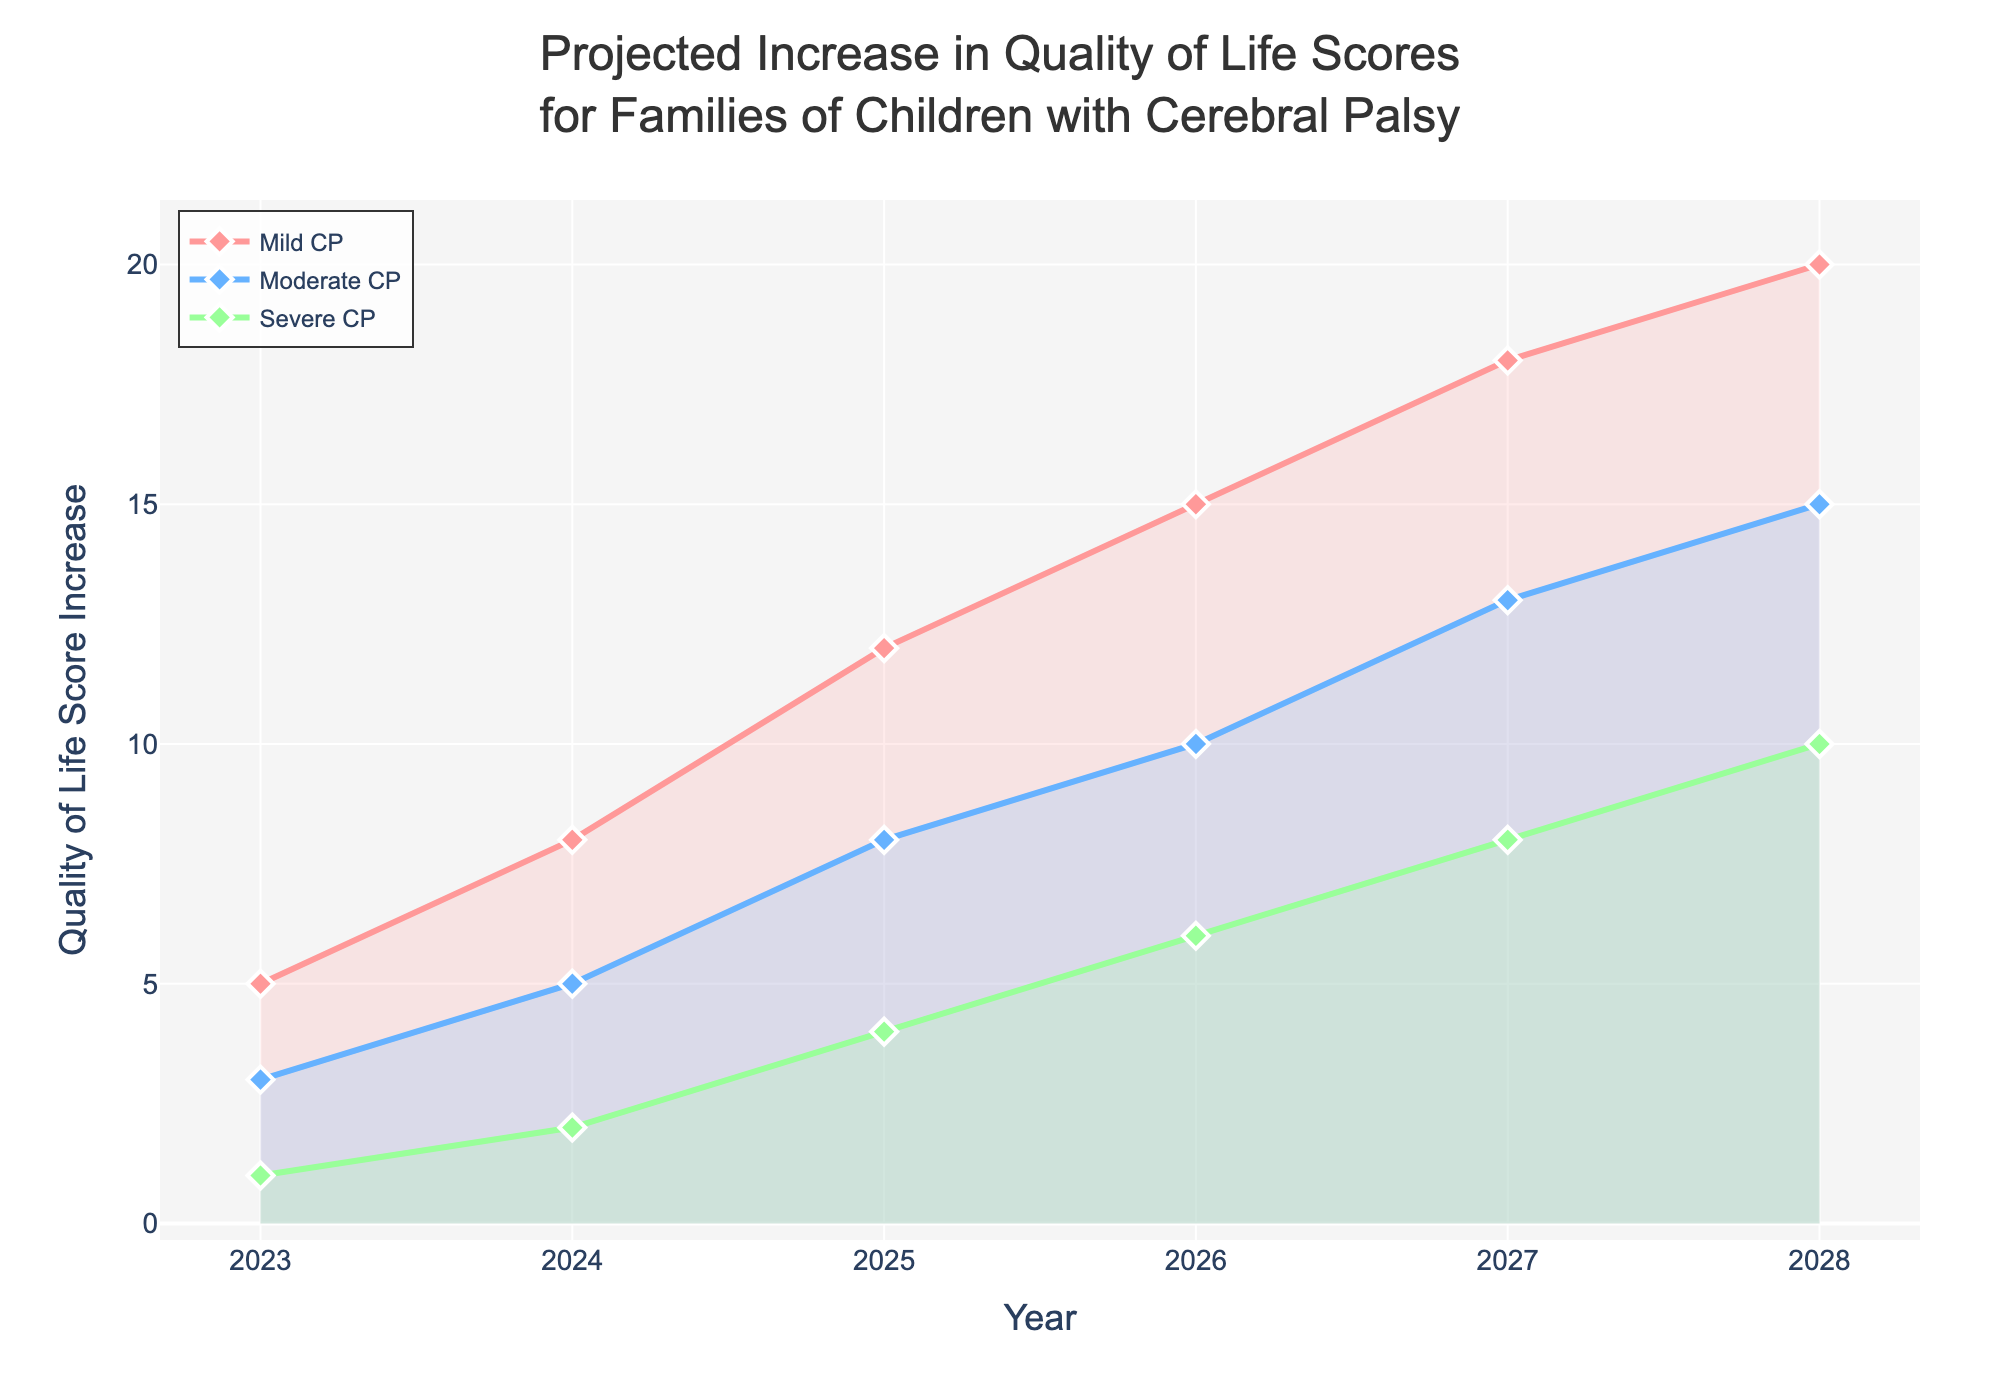What is the title of the figure? The title of the figure is found at the top and summarizes the main topic of the chart.
Answer: Projected Increase in Quality of Life Scores for Families of Children with Cerebral Palsy Which years are represented on the x-axis? The years are listed along the horizontal axis at the bottom of the chart.
Answer: 2023, 2024, 2025, 2026, 2027, 2028 Which condition shows the highest projected increase in quality of life scores by 2028? By looking at the endpoint of each colored line on the right side of the chart, the condition with the highest value is the one with the most increase.
Answer: Mild CP How does the projected increase for Severe CP compare to Moderate CP in 2027? Check the values for both conditions in 2027 and see which one is higher.
Answer: Moderate CP is higher What is the difference in the projected increase in quality of life scores for Mild CP between 2024 and 2026? Subtract the value in 2024 from the value in 2026 for Mild CP.
Answer: 15 - 8 = 7 How much is the quality of life score projected to increase from 2023 to 2028 for Moderate CP? Subtract the value in 2023 from the value in 2028 for Moderate CP.
Answer: 15 - 3 = 12 Which year shows the highest increase in quality of life scores for Severe CP from the previous year? Look at the differences in scores from year to year for Severe CP and determine the largest increase.
Answer: 2027-2026 By what factor does the quality of life score for Severe CP increase from 2023 to 2028? Divide the value in 2028 by the value in 2023 for Severe CP.
Answer: 10 / 1 = 10 What pattern can be observed in the projected quality of life scores for each condition over the six-year period? Describe the general trend observed in each condition's line over the years.
Answer: Increasing trend for all conditions 